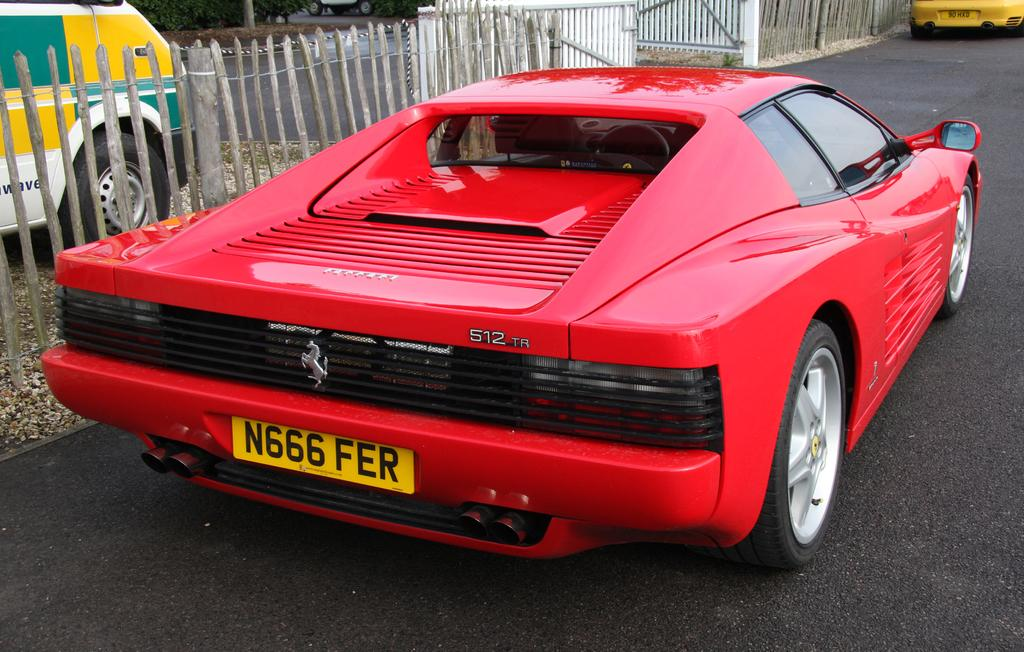What can be seen in the image that moves or travels? There are vehicles in the image that move or travel. What surface do the vehicles move on in the image? There is a road in the image where the vehicles move. What separates the road from the background in the image? There is a fence in the image that separates the road from the background. What type of natural elements can be seen in the background of the image? There are plants in the background of the image. Can you see any crackers floating on the lake in the image? There is no lake or crackers present in the image. 